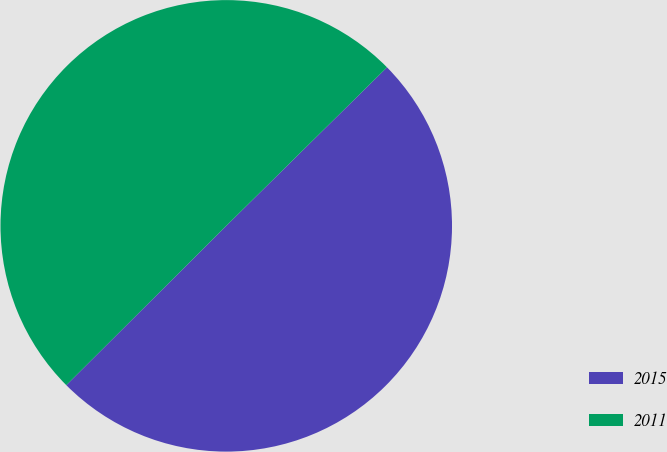Convert chart. <chart><loc_0><loc_0><loc_500><loc_500><pie_chart><fcel>2015<fcel>2011<nl><fcel>49.92%<fcel>50.08%<nl></chart> 